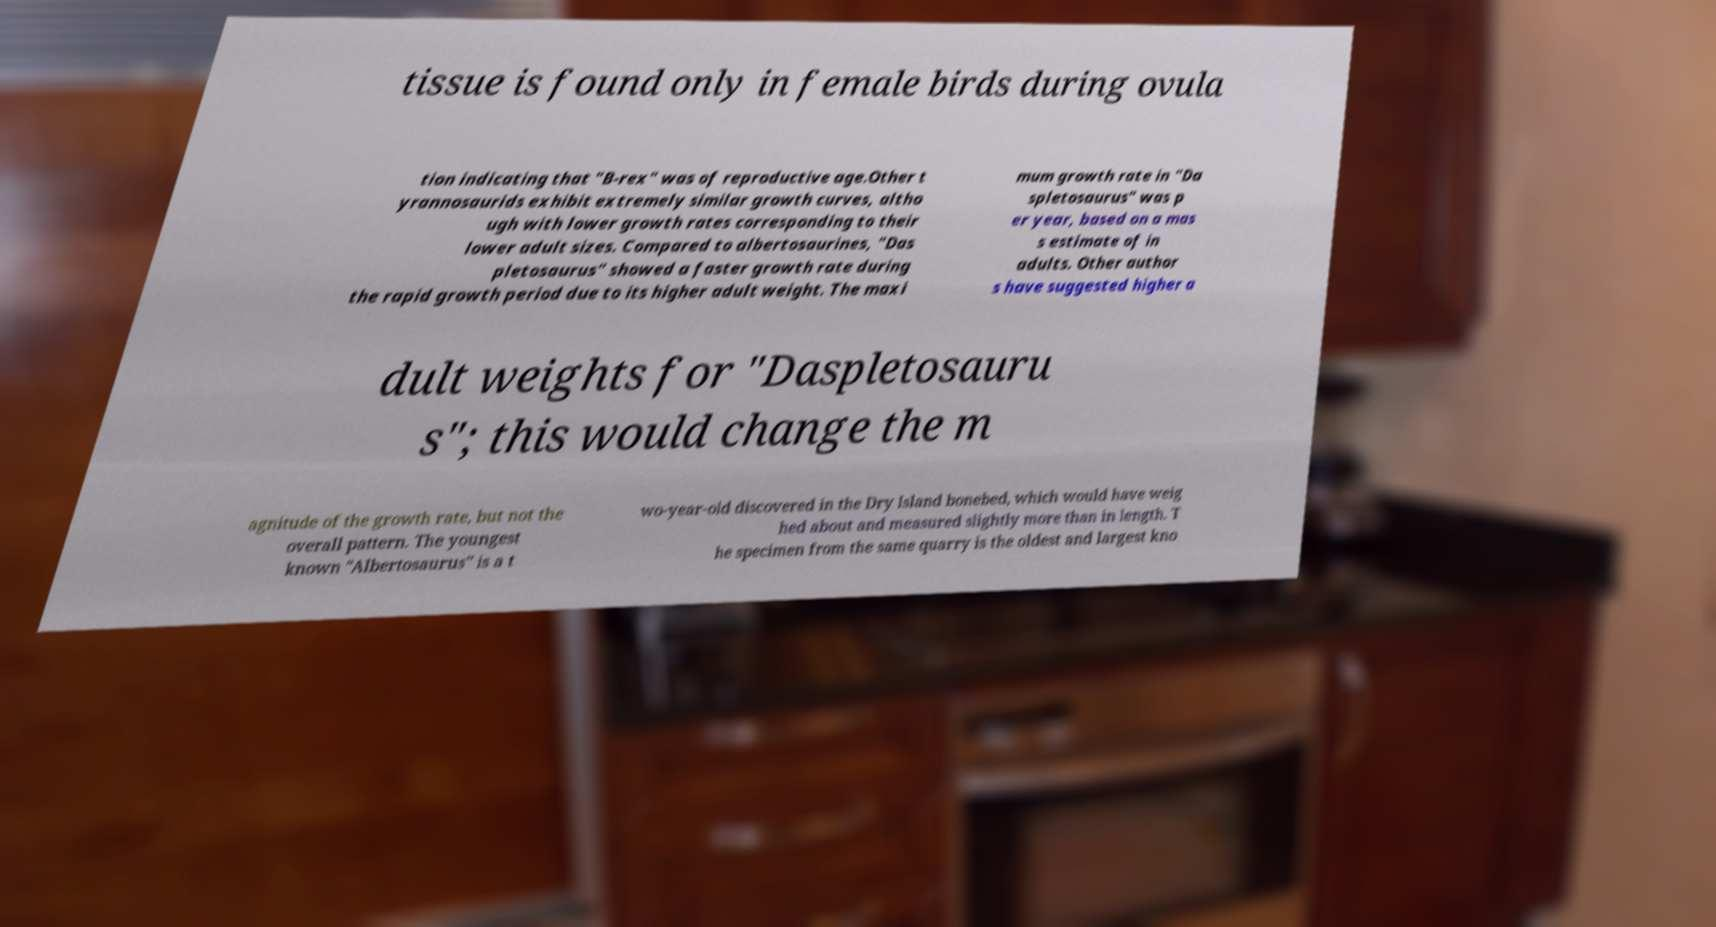Can you read and provide the text displayed in the image?This photo seems to have some interesting text. Can you extract and type it out for me? tissue is found only in female birds during ovula tion indicating that "B-rex" was of reproductive age.Other t yrannosaurids exhibit extremely similar growth curves, altho ugh with lower growth rates corresponding to their lower adult sizes. Compared to albertosaurines, "Das pletosaurus" showed a faster growth rate during the rapid growth period due to its higher adult weight. The maxi mum growth rate in "Da spletosaurus" was p er year, based on a mas s estimate of in adults. Other author s have suggested higher a dult weights for "Daspletosauru s"; this would change the m agnitude of the growth rate, but not the overall pattern. The youngest known "Albertosaurus" is a t wo-year-old discovered in the Dry Island bonebed, which would have weig hed about and measured slightly more than in length. T he specimen from the same quarry is the oldest and largest kno 